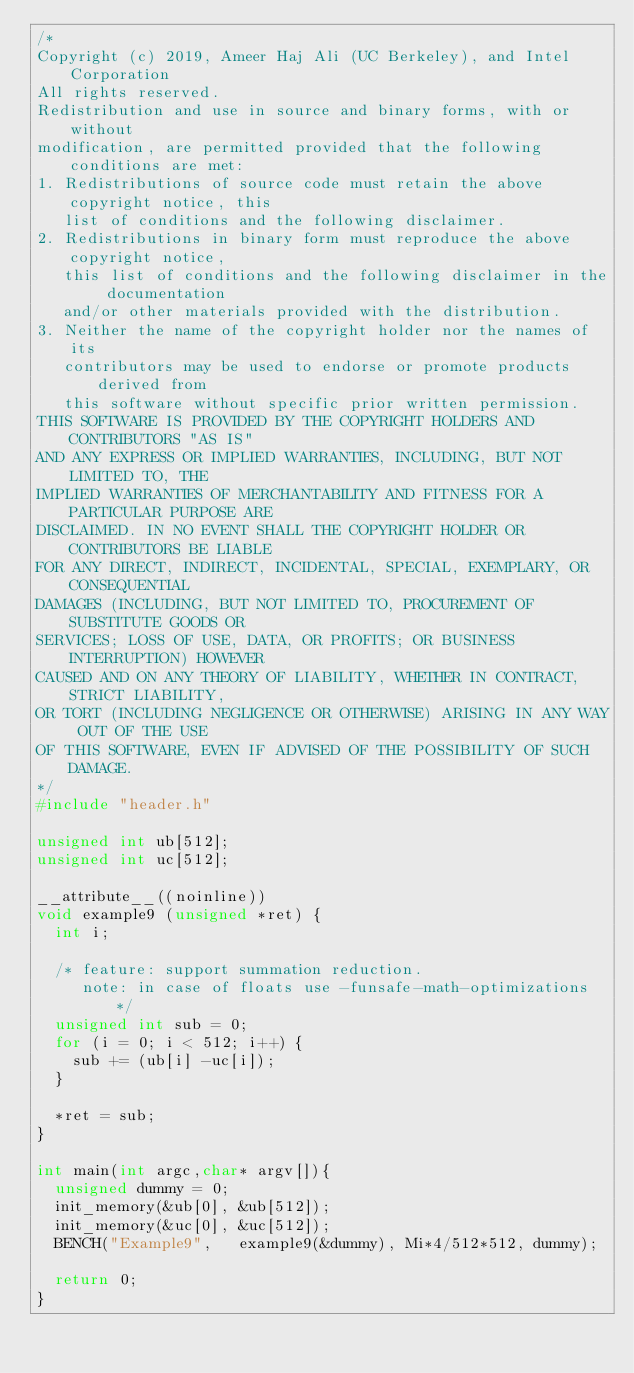<code> <loc_0><loc_0><loc_500><loc_500><_C_>/*
Copyright (c) 2019, Ameer Haj Ali (UC Berkeley), and Intel Corporation
All rights reserved.
Redistribution and use in source and binary forms, with or without
modification, are permitted provided that the following conditions are met:
1. Redistributions of source code must retain the above copyright notice, this
   list of conditions and the following disclaimer.
2. Redistributions in binary form must reproduce the above copyright notice,
   this list of conditions and the following disclaimer in the documentation
   and/or other materials provided with the distribution.
3. Neither the name of the copyright holder nor the names of its
   contributors may be used to endorse or promote products derived from
   this software without specific prior written permission.
THIS SOFTWARE IS PROVIDED BY THE COPYRIGHT HOLDERS AND CONTRIBUTORS "AS IS"
AND ANY EXPRESS OR IMPLIED WARRANTIES, INCLUDING, BUT NOT LIMITED TO, THE
IMPLIED WARRANTIES OF MERCHANTABILITY AND FITNESS FOR A PARTICULAR PURPOSE ARE
DISCLAIMED. IN NO EVENT SHALL THE COPYRIGHT HOLDER OR CONTRIBUTORS BE LIABLE
FOR ANY DIRECT, INDIRECT, INCIDENTAL, SPECIAL, EXEMPLARY, OR CONSEQUENTIAL
DAMAGES (INCLUDING, BUT NOT LIMITED TO, PROCUREMENT OF SUBSTITUTE GOODS OR
SERVICES; LOSS OF USE, DATA, OR PROFITS; OR BUSINESS INTERRUPTION) HOWEVER
CAUSED AND ON ANY THEORY OF LIABILITY, WHETHER IN CONTRACT, STRICT LIABILITY,
OR TORT (INCLUDING NEGLIGENCE OR OTHERWISE) ARISING IN ANY WAY OUT OF THE USE
OF THIS SOFTWARE, EVEN IF ADVISED OF THE POSSIBILITY OF SUCH DAMAGE.
*/
#include "header.h"

unsigned int ub[512];
unsigned int uc[512];

__attribute__((noinline))
void example9 (unsigned *ret) {
  int i;

  /* feature: support summation reduction.
     note: in case of floats use -funsafe-math-optimizations  */
  unsigned int sub = 0;
  for (i = 0; i < 512; i++) {
    sub += (ub[i] -uc[i]);
  }

  *ret = sub;
}

int main(int argc,char* argv[]){
  unsigned dummy = 0;
  init_memory(&ub[0], &ub[512]);
  init_memory(&uc[0], &uc[512]);
  BENCH("Example9",   example9(&dummy), Mi*4/512*512, dummy);
 
  return 0;
}
</code> 